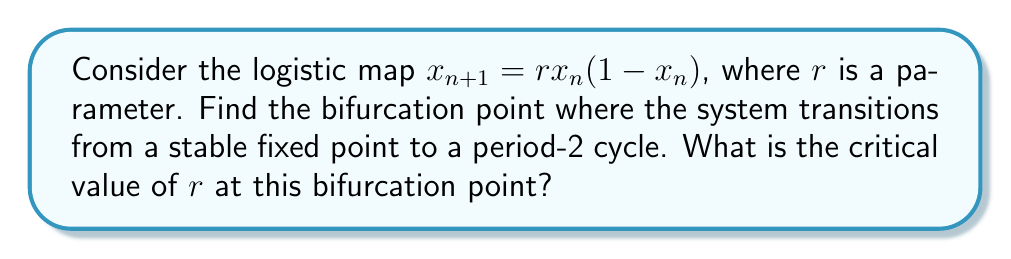Could you help me with this problem? To find the bifurcation point, we need to follow these steps:

1) First, find the fixed points of the system by solving:
   $x = rx(1-x)$
   
   Solving this equation:
   $x = rx - rx^2$
   $rx^2 - rx + x = 0$
   $x(rx - r + 1) = 0$
   
   So, $x = 0$ or $x = 1 - \frac{1}{r}$

2) The non-zero fixed point $x^* = 1 - \frac{1}{r}$ is of interest.

3) To determine stability, we need to find the derivative of the map at this fixed point:
   $f'(x) = r(1-2x)$
   
   At $x^*$: $f'(x^*) = r(1-2(1-\frac{1}{r})) = r(1-2+\frac{2}{r}) = 2-r$

4) The fixed point loses stability when $|f'(x^*)| = 1$. In this case, we're looking for where it becomes less than -1 (period-doubling bifurcation).

   $2-r = -1$
   $r = 3$

5) Therefore, the critical value of $r$ at the bifurcation point is 3.

This can be verified by iterating the map for values of $r$ slightly below and above 3, observing the transition from a stable fixed point to a period-2 cycle.
Answer: $r = 3$ 